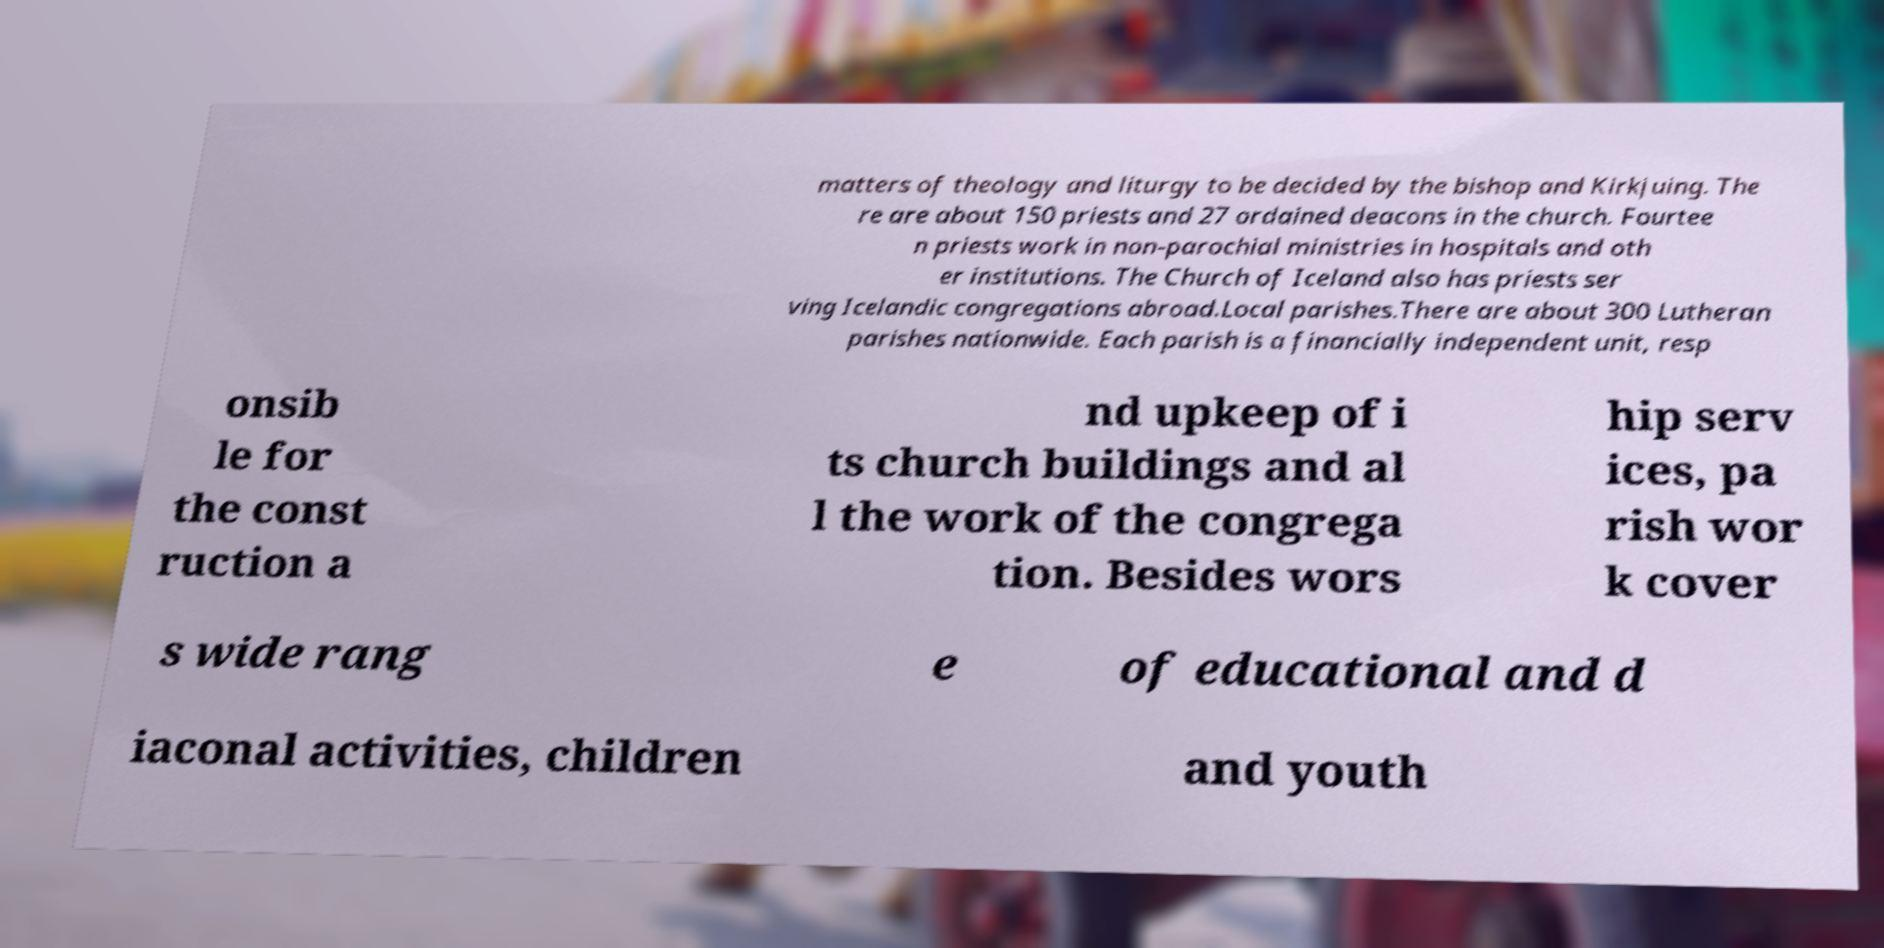Can you read and provide the text displayed in the image?This photo seems to have some interesting text. Can you extract and type it out for me? matters of theology and liturgy to be decided by the bishop and Kirkjuing. The re are about 150 priests and 27 ordained deacons in the church. Fourtee n priests work in non-parochial ministries in hospitals and oth er institutions. The Church of Iceland also has priests ser ving Icelandic congregations abroad.Local parishes.There are about 300 Lutheran parishes nationwide. Each parish is a financially independent unit, resp onsib le for the const ruction a nd upkeep of i ts church buildings and al l the work of the congrega tion. Besides wors hip serv ices, pa rish wor k cover s wide rang e of educational and d iaconal activities, children and youth 